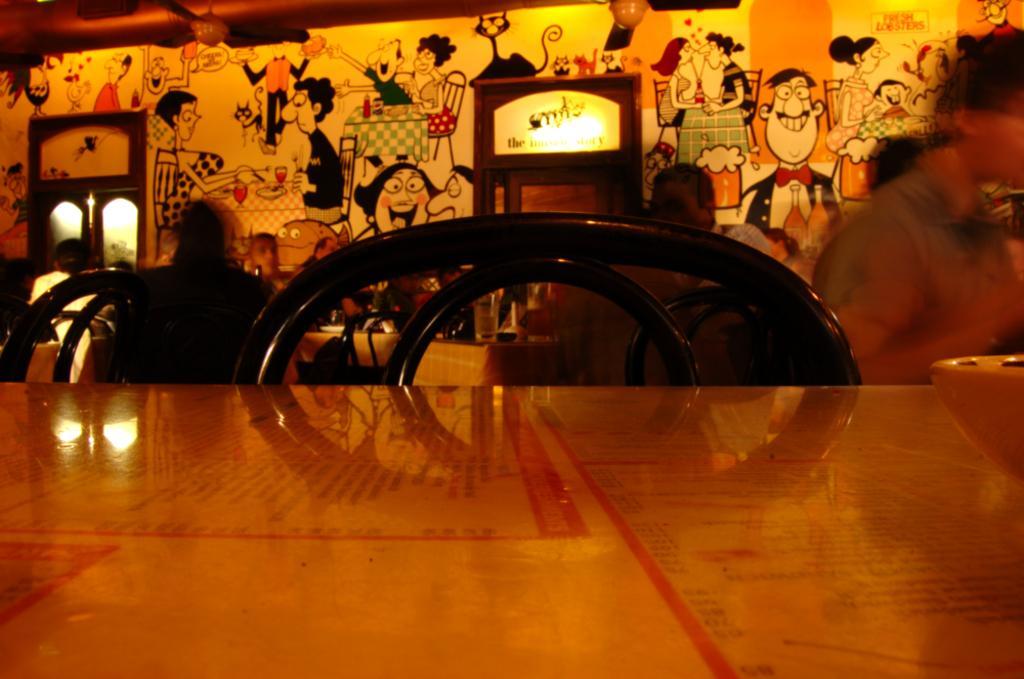Describe this image in one or two sentences. In this image I can see the brown color table and the black color chair. To the side I can see the bowl on the table. In the back there are few people with different color dresses and I can see the colorful wall in the back. 